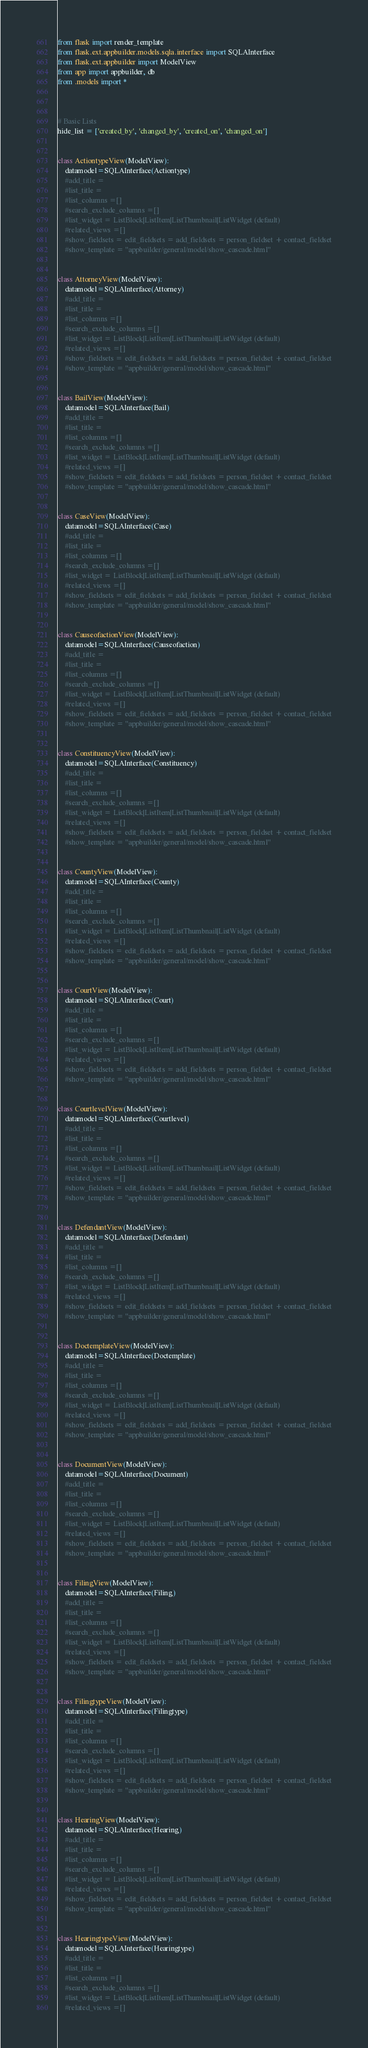<code> <loc_0><loc_0><loc_500><loc_500><_Python_>from flask import render_template
from flask.ext.appbuilder.models.sqla.interface import SQLAInterface
from flask.ext.appbuilder import ModelView
from app import appbuilder, db
from .models import *
 
 
 
# Basic Lists 
hide_list = ['created_by', 'changed_by', 'created_on', 'changed_on'] 
 
 
class ActiontypeView(ModelView):
	datamodel=SQLAInterface(Actiontype)
	#add_title =
	#list_title =
	#list_columns =[]
	#search_exclude_columns =[]
	#list_widget = ListBlock|ListItem|ListThumbnail|ListWidget (default)
	#related_views =[]
	#show_fieldsets = edit_fieldsets = add_fieldsets = person_fieldset + contact_fieldset
	#show_template = "appbuilder/general/model/show_cascade.html"


class AttorneyView(ModelView):
	datamodel=SQLAInterface(Attorney)
	#add_title =
	#list_title =
	#list_columns =[]
	#search_exclude_columns =[]
	#list_widget = ListBlock|ListItem|ListThumbnail|ListWidget (default)
	#related_views =[]
	#show_fieldsets = edit_fieldsets = add_fieldsets = person_fieldset + contact_fieldset
	#show_template = "appbuilder/general/model/show_cascade.html"


class BailView(ModelView):
	datamodel=SQLAInterface(Bail)
	#add_title =
	#list_title =
	#list_columns =[]
	#search_exclude_columns =[]
	#list_widget = ListBlock|ListItem|ListThumbnail|ListWidget (default)
	#related_views =[]
	#show_fieldsets = edit_fieldsets = add_fieldsets = person_fieldset + contact_fieldset
	#show_template = "appbuilder/general/model/show_cascade.html"


class CaseView(ModelView):
	datamodel=SQLAInterface(Case)
	#add_title =
	#list_title =
	#list_columns =[]
	#search_exclude_columns =[]
	#list_widget = ListBlock|ListItem|ListThumbnail|ListWidget (default)
	#related_views =[]
	#show_fieldsets = edit_fieldsets = add_fieldsets = person_fieldset + contact_fieldset
	#show_template = "appbuilder/general/model/show_cascade.html"


class CauseofactionView(ModelView):
	datamodel=SQLAInterface(Causeofaction)
	#add_title =
	#list_title =
	#list_columns =[]
	#search_exclude_columns =[]
	#list_widget = ListBlock|ListItem|ListThumbnail|ListWidget (default)
	#related_views =[]
	#show_fieldsets = edit_fieldsets = add_fieldsets = person_fieldset + contact_fieldset
	#show_template = "appbuilder/general/model/show_cascade.html"


class ConstituencyView(ModelView):
	datamodel=SQLAInterface(Constituency)
	#add_title =
	#list_title =
	#list_columns =[]
	#search_exclude_columns =[]
	#list_widget = ListBlock|ListItem|ListThumbnail|ListWidget (default)
	#related_views =[]
	#show_fieldsets = edit_fieldsets = add_fieldsets = person_fieldset + contact_fieldset
	#show_template = "appbuilder/general/model/show_cascade.html"


class CountyView(ModelView):
	datamodel=SQLAInterface(County)
	#add_title =
	#list_title =
	#list_columns =[]
	#search_exclude_columns =[]
	#list_widget = ListBlock|ListItem|ListThumbnail|ListWidget (default)
	#related_views =[]
	#show_fieldsets = edit_fieldsets = add_fieldsets = person_fieldset + contact_fieldset
	#show_template = "appbuilder/general/model/show_cascade.html"


class CourtView(ModelView):
	datamodel=SQLAInterface(Court)
	#add_title =
	#list_title =
	#list_columns =[]
	#search_exclude_columns =[]
	#list_widget = ListBlock|ListItem|ListThumbnail|ListWidget (default)
	#related_views =[]
	#show_fieldsets = edit_fieldsets = add_fieldsets = person_fieldset + contact_fieldset
	#show_template = "appbuilder/general/model/show_cascade.html"


class CourtlevelView(ModelView):
	datamodel=SQLAInterface(Courtlevel)
	#add_title =
	#list_title =
	#list_columns =[]
	#search_exclude_columns =[]
	#list_widget = ListBlock|ListItem|ListThumbnail|ListWidget (default)
	#related_views =[]
	#show_fieldsets = edit_fieldsets = add_fieldsets = person_fieldset + contact_fieldset
	#show_template = "appbuilder/general/model/show_cascade.html"


class DefendantView(ModelView):
	datamodel=SQLAInterface(Defendant)
	#add_title =
	#list_title =
	#list_columns =[]
	#search_exclude_columns =[]
	#list_widget = ListBlock|ListItem|ListThumbnail|ListWidget (default)
	#related_views =[]
	#show_fieldsets = edit_fieldsets = add_fieldsets = person_fieldset + contact_fieldset
	#show_template = "appbuilder/general/model/show_cascade.html"


class DoctemplateView(ModelView):
	datamodel=SQLAInterface(Doctemplate)
	#add_title =
	#list_title =
	#list_columns =[]
	#search_exclude_columns =[]
	#list_widget = ListBlock|ListItem|ListThumbnail|ListWidget (default)
	#related_views =[]
	#show_fieldsets = edit_fieldsets = add_fieldsets = person_fieldset + contact_fieldset
	#show_template = "appbuilder/general/model/show_cascade.html"


class DocumentView(ModelView):
	datamodel=SQLAInterface(Document)
	#add_title =
	#list_title =
	#list_columns =[]
	#search_exclude_columns =[]
	#list_widget = ListBlock|ListItem|ListThumbnail|ListWidget (default)
	#related_views =[]
	#show_fieldsets = edit_fieldsets = add_fieldsets = person_fieldset + contact_fieldset
	#show_template = "appbuilder/general/model/show_cascade.html"


class FilingView(ModelView):
	datamodel=SQLAInterface(Filing)
	#add_title =
	#list_title =
	#list_columns =[]
	#search_exclude_columns =[]
	#list_widget = ListBlock|ListItem|ListThumbnail|ListWidget (default)
	#related_views =[]
	#show_fieldsets = edit_fieldsets = add_fieldsets = person_fieldset + contact_fieldset
	#show_template = "appbuilder/general/model/show_cascade.html"


class FilingtypeView(ModelView):
	datamodel=SQLAInterface(Filingtype)
	#add_title =
	#list_title =
	#list_columns =[]
	#search_exclude_columns =[]
	#list_widget = ListBlock|ListItem|ListThumbnail|ListWidget (default)
	#related_views =[]
	#show_fieldsets = edit_fieldsets = add_fieldsets = person_fieldset + contact_fieldset
	#show_template = "appbuilder/general/model/show_cascade.html"


class HearingView(ModelView):
	datamodel=SQLAInterface(Hearing)
	#add_title =
	#list_title =
	#list_columns =[]
	#search_exclude_columns =[]
	#list_widget = ListBlock|ListItem|ListThumbnail|ListWidget (default)
	#related_views =[]
	#show_fieldsets = edit_fieldsets = add_fieldsets = person_fieldset + contact_fieldset
	#show_template = "appbuilder/general/model/show_cascade.html"


class HearingtypeView(ModelView):
	datamodel=SQLAInterface(Hearingtype)
	#add_title =
	#list_title =
	#list_columns =[]
	#search_exclude_columns =[]
	#list_widget = ListBlock|ListItem|ListThumbnail|ListWidget (default)
	#related_views =[]</code> 